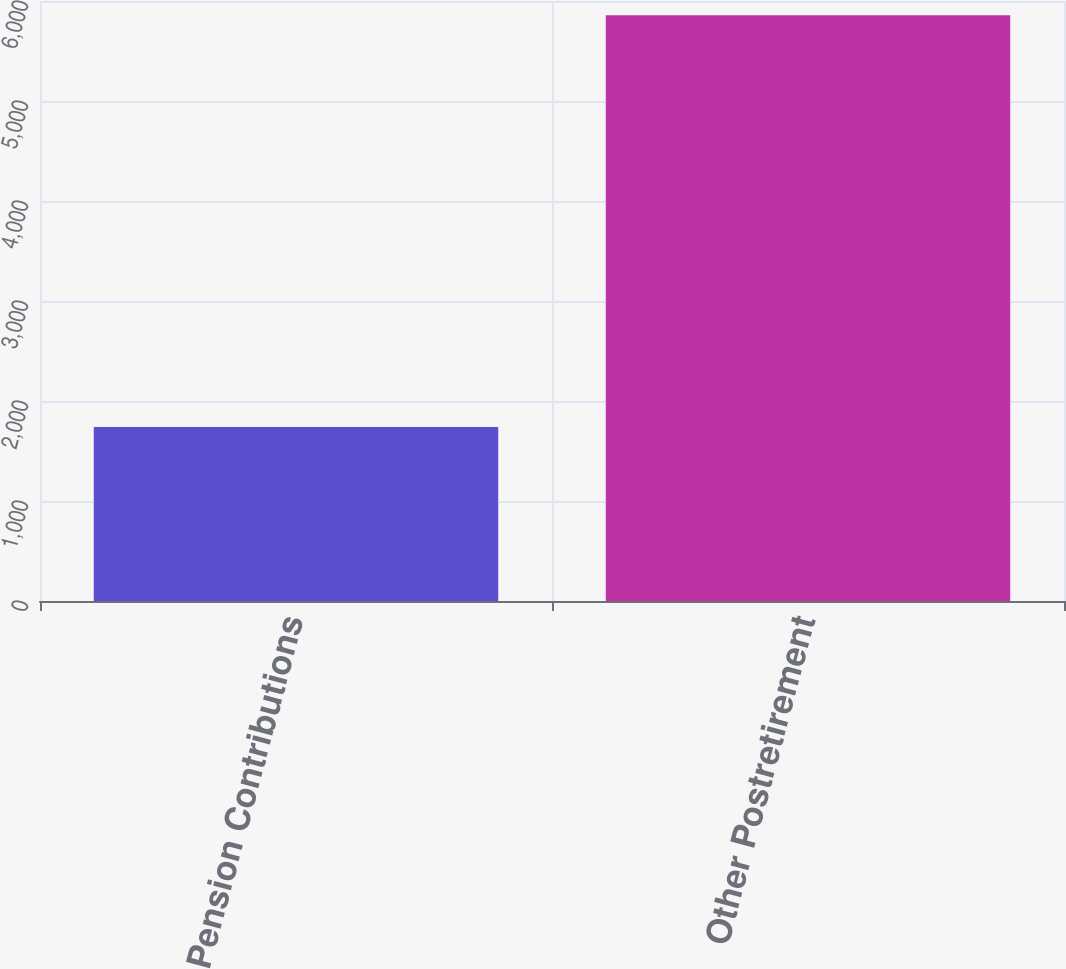Convert chart to OTSL. <chart><loc_0><loc_0><loc_500><loc_500><bar_chart><fcel>Pension Contributions<fcel>Other Postretirement<nl><fcel>1739<fcel>5858<nl></chart> 